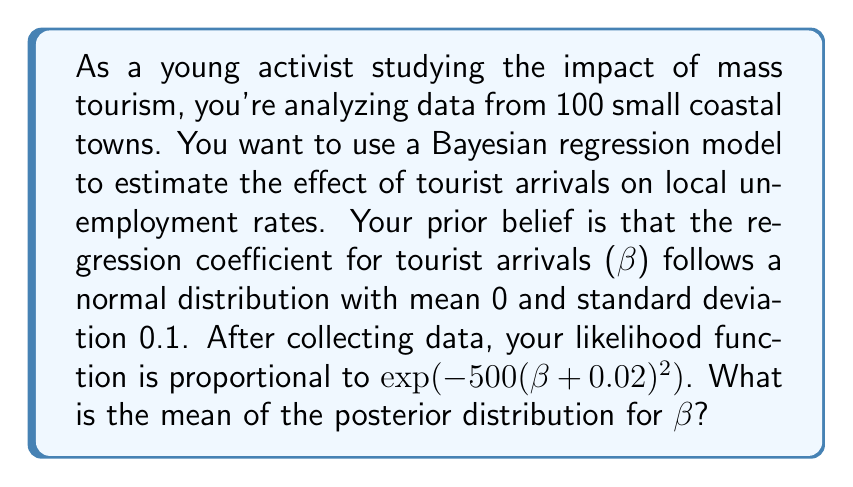Teach me how to tackle this problem. To solve this problem, we'll use Bayesian inference to update our prior belief with the observed data. Let's break it down step-by-step:

1) Prior distribution:
   $\beta \sim N(0, 0.1^2)$

2) Likelihood function:
   $L(\beta) \propto \exp(-500(\beta+0.02)^2)$

3) The posterior distribution is proportional to the product of the prior and likelihood:
   $p(\beta|data) \propto p(\beta) \cdot L(\beta)$

4) Let's write out the full expressions:
   $p(\beta|data) \propto \exp(-\frac{(\beta-0)^2}{2(0.1^2)}) \cdot \exp(-500(\beta+0.02)^2)$

5) Combining the exponents:
   $p(\beta|data) \propto \exp(-50\beta^2 - 500(\beta^2 + 0.04\beta + 0.0004))$
   $\propto \exp(-550\beta^2 - 20\beta - 0.2)$

6) The posterior distribution is also normal. For a normal distribution, the exponent should be in the form:
   $-\frac{1}{2\sigma^2}(\beta - \mu)^2$

7) Expanding this form:
   $-\frac{1}{2\sigma^2}(\beta^2 - 2\mu\beta + \mu^2)$

8) Comparing with our exponent:
   $-550\beta^2 - 20\beta = -\frac{1}{2\sigma^2}(\beta^2 - 2\mu\beta)$

9) From this, we can deduce:
   $\frac{1}{2\sigma^2} = 550$
   $\frac{\mu}{\sigma^2} = 10$

10) Solving these equations:
    $\sigma^2 = \frac{1}{1100}$
    $\mu = \frac{10}{1100} = -\frac{1}{110}$

Therefore, the mean of the posterior distribution is $-\frac{1}{110} \approx -0.00909$.
Answer: $-\frac{1}{110}$ or approximately $-0.00909$ 